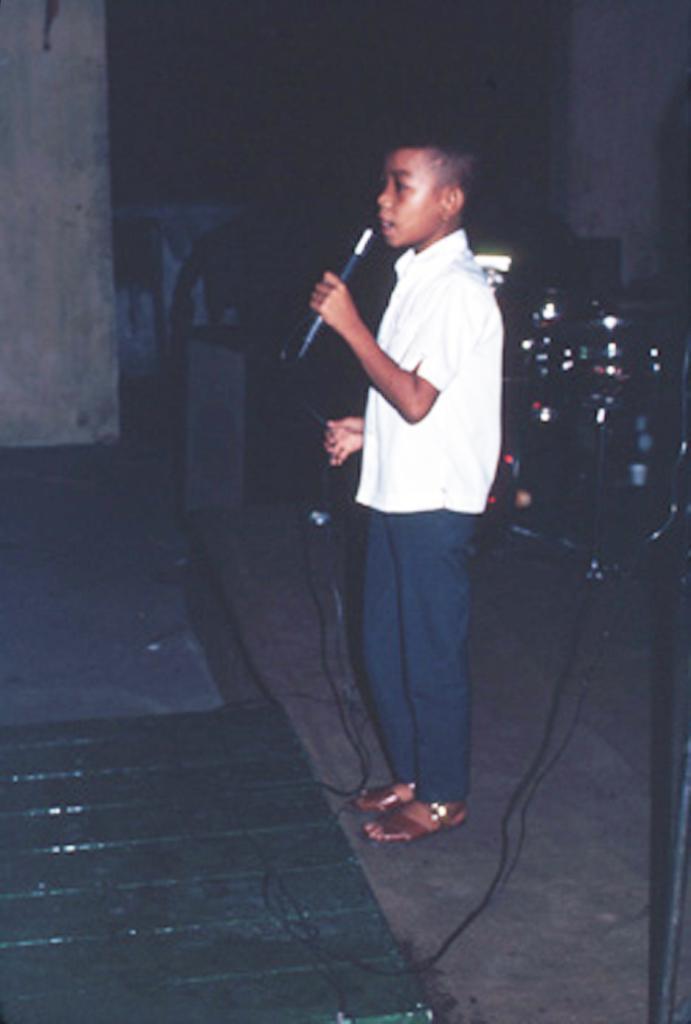Please provide a concise description of this image. In this image we can see a child standing on the floor holding a mic with a wire. On the backside we can see some musical instruments and a wall. 